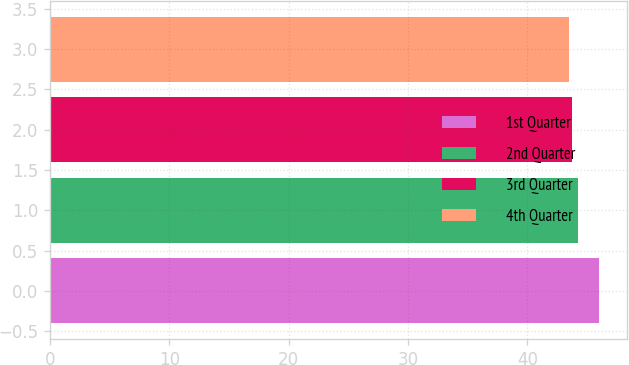<chart> <loc_0><loc_0><loc_500><loc_500><bar_chart><fcel>1st Quarter<fcel>2nd Quarter<fcel>3rd Quarter<fcel>4th Quarter<nl><fcel>46.02<fcel>44.26<fcel>43.78<fcel>43.48<nl></chart> 